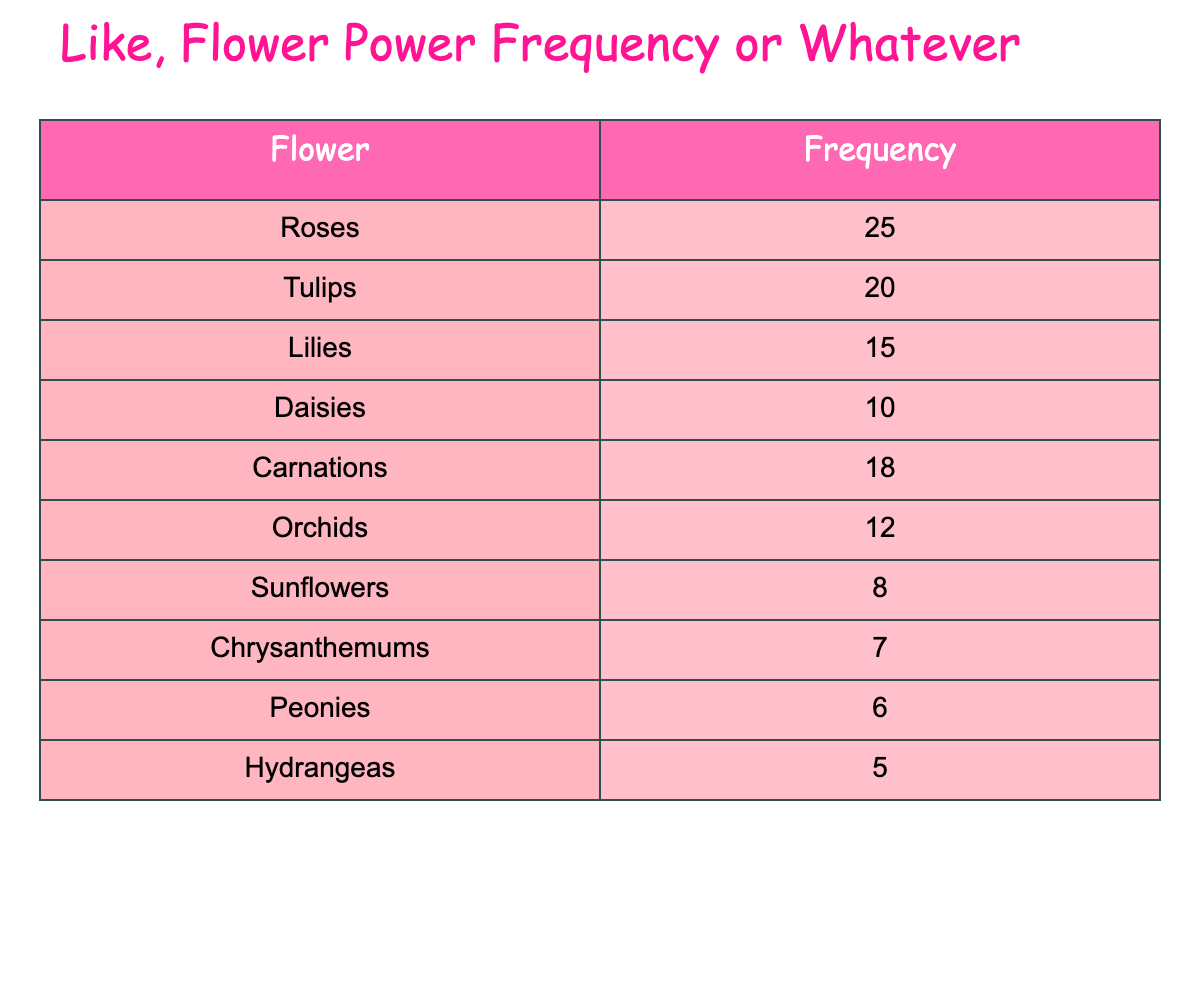What flower has the highest frequency in floral arrangements? According to the table, "Roses" have the highest frequency at 25 occurrences, as it is listed first in the row with the highest number.
Answer: Roses How many fewer "Sunflowers" are used compared to "Carnations"? The frequency of "Sunflowers" is 8, and for "Carnations," it is 18. The difference is calculated as 18 - 8 = 10.
Answer: 10 What is the frequency of "Peonies"? The table shows that "Peonies" have a frequency of 6, as it is specifically listed in the rows.
Answer: 6 Are "Orchids" more common than "Chrysanthemums"? "Orchids" have a frequency of 12 and "Chrysanthemums" have a frequency of 7. Since 12 is greater than 7, the statement is true.
Answer: Yes What is the total frequency of "Lilies", "Daisies", and "Hydrangeas"? The frequencies of these flowers are 15 (Lilies), 10 (Daisies), and 5 (Hydrangeas). To find the total, we sum them: 15 + 10 + 5 = 30.
Answer: 30 How many flowers have a frequency of 10 or fewer? Looking at the table, we see that "Sunflowers" (8), "Chrysanthemums" (7), "Peonies" (6), and "Hydrangeas" (5) all have frequencies of 10 or fewer. That's a total of 4 flowers.
Answer: 4 What is the most common flower used after "Roses"? The flower that comes after "Roses" in frequency is "Tulips," with a frequency of 20, as seen in the second row.
Answer: Tulips If you combine the frequencies of "Tulips" and "Carnations," what do you get? The frequency of "Tulips" is 20 and "Carnations" is 18, so when we add these together: 20 + 18 = 38.
Answer: 38 Which flower has a frequency of exactly 12? From the table, "Orchids" have a frequency of exactly 12, clearly stated in their row of data.
Answer: Orchids 